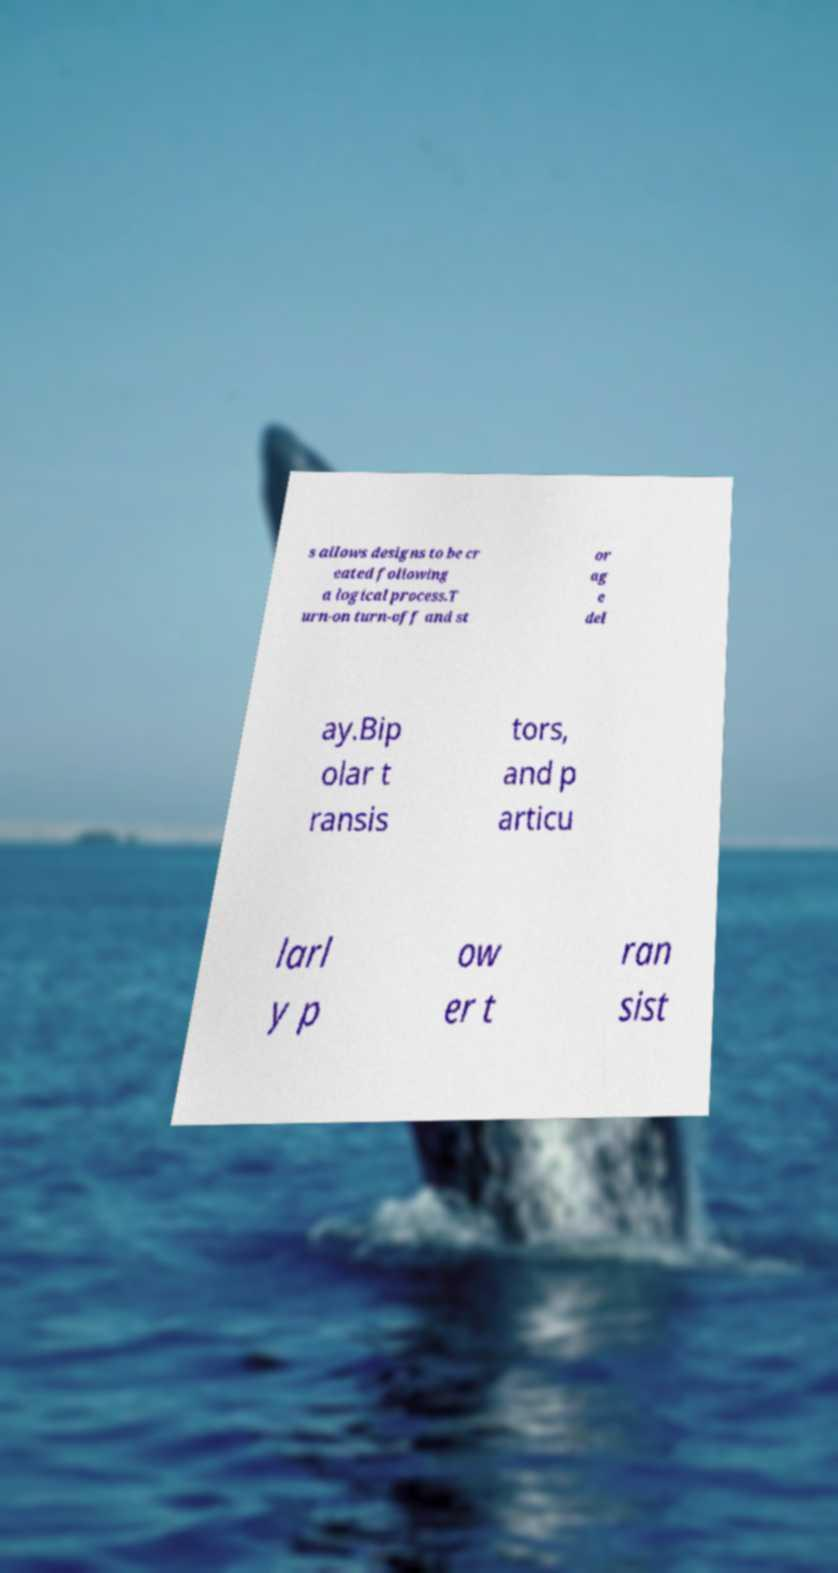Could you assist in decoding the text presented in this image and type it out clearly? s allows designs to be cr eated following a logical process.T urn-on turn-off and st or ag e del ay.Bip olar t ransis tors, and p articu larl y p ow er t ran sist 